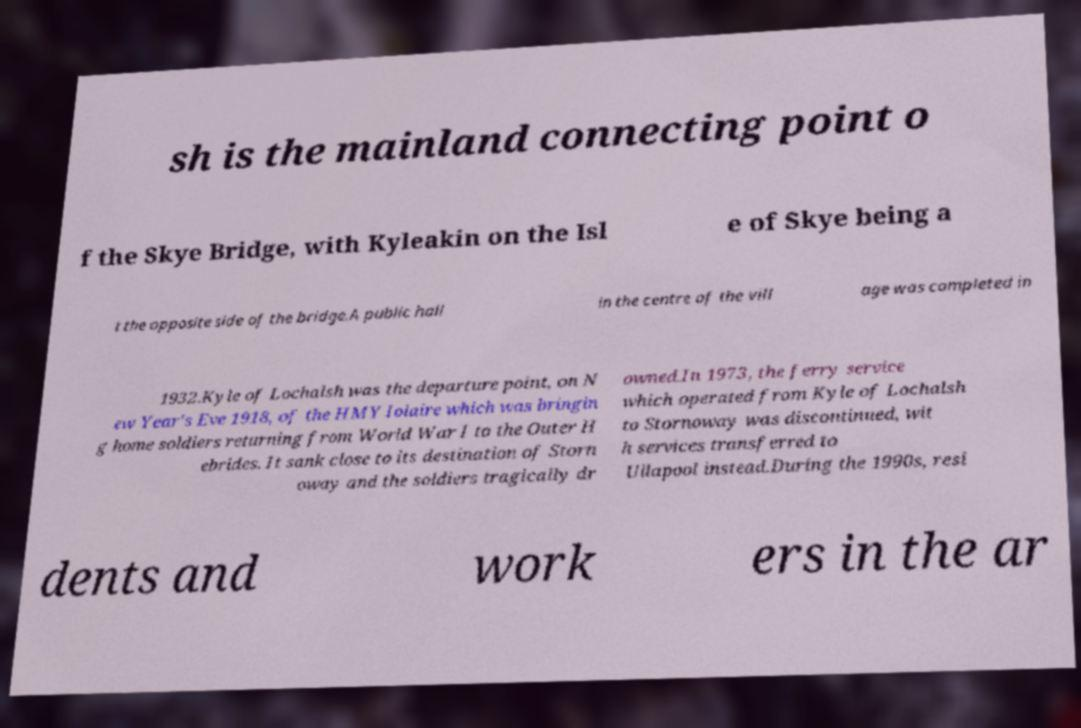For documentation purposes, I need the text within this image transcribed. Could you provide that? sh is the mainland connecting point o f the Skye Bridge, with Kyleakin on the Isl e of Skye being a t the opposite side of the bridge.A public hall in the centre of the vill age was completed in 1932.Kyle of Lochalsh was the departure point, on N ew Year's Eve 1918, of the HMY Iolaire which was bringin g home soldiers returning from World War I to the Outer H ebrides. It sank close to its destination of Storn oway and the soldiers tragically dr owned.In 1973, the ferry service which operated from Kyle of Lochalsh to Stornoway was discontinued, wit h services transferred to Ullapool instead.During the 1990s, resi dents and work ers in the ar 